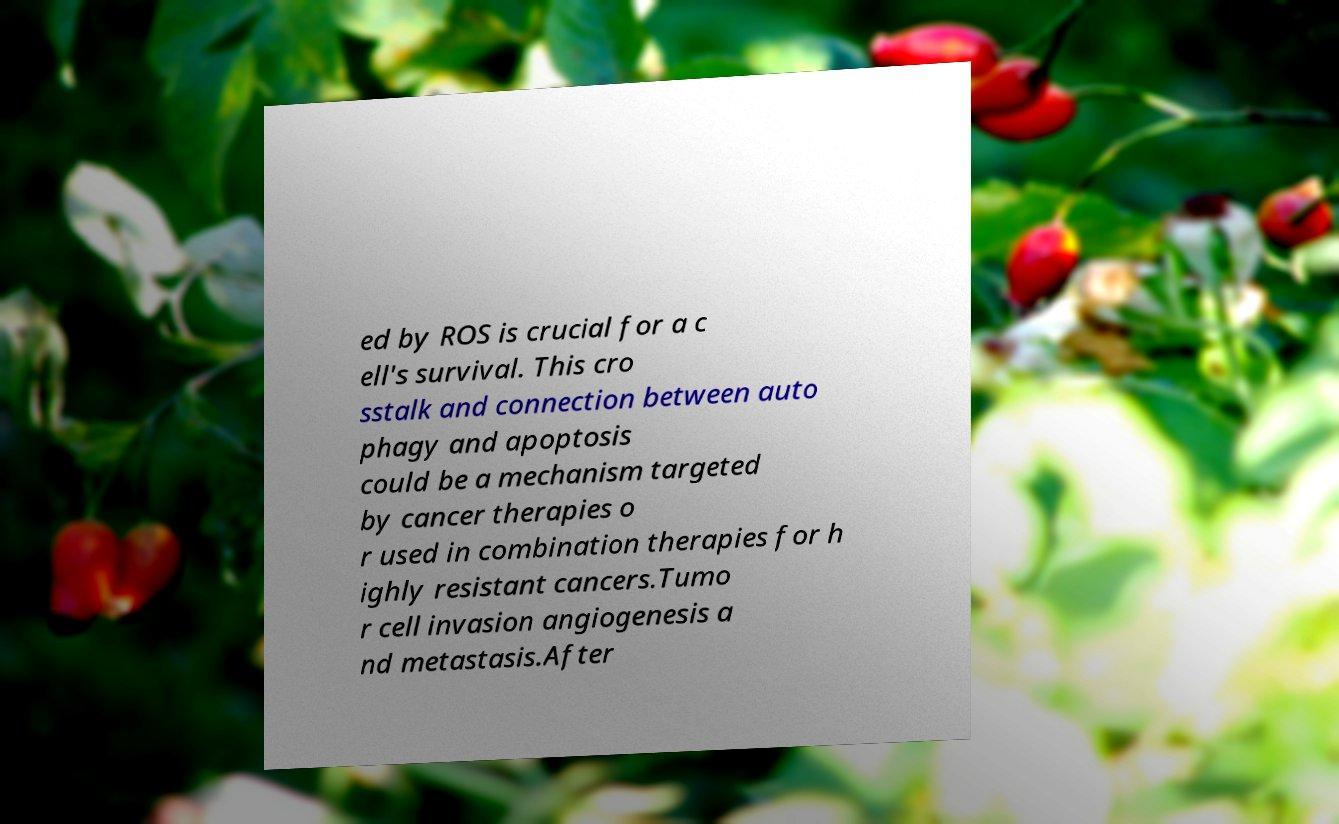Could you assist in decoding the text presented in this image and type it out clearly? ed by ROS is crucial for a c ell's survival. This cro sstalk and connection between auto phagy and apoptosis could be a mechanism targeted by cancer therapies o r used in combination therapies for h ighly resistant cancers.Tumo r cell invasion angiogenesis a nd metastasis.After 